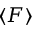<formula> <loc_0><loc_0><loc_500><loc_500>\langle F \rangle</formula> 